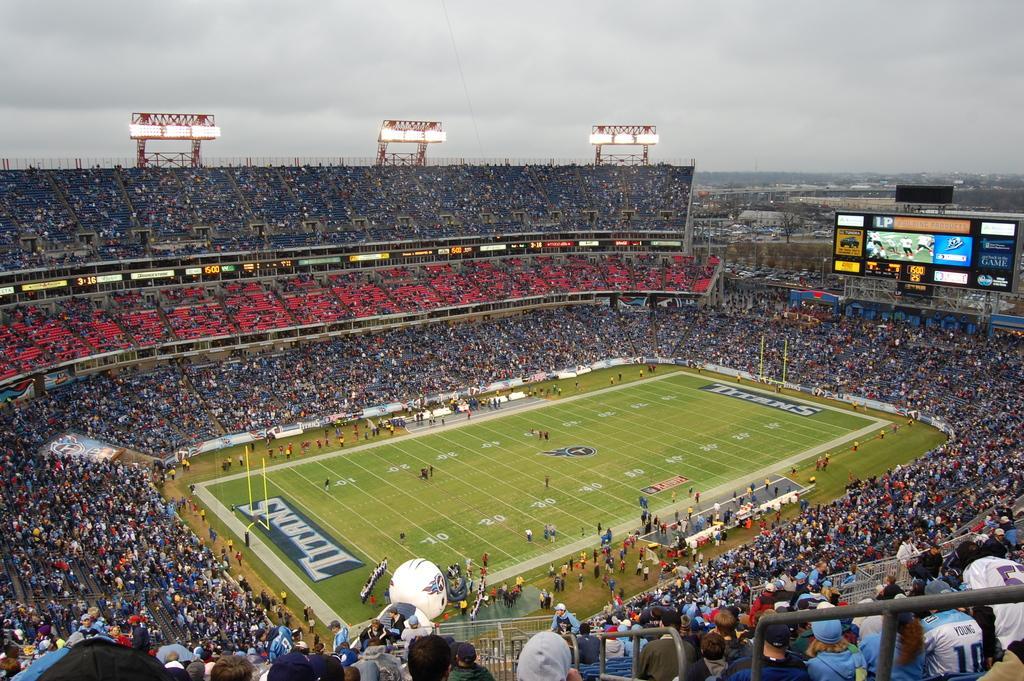Describe this image in one or two sentences. The image is taken in the stadium. In the center of the image there is a ground and we can see people playing a game. There is crowd. On the right we can see a screen. At the top there are lights and sky. 